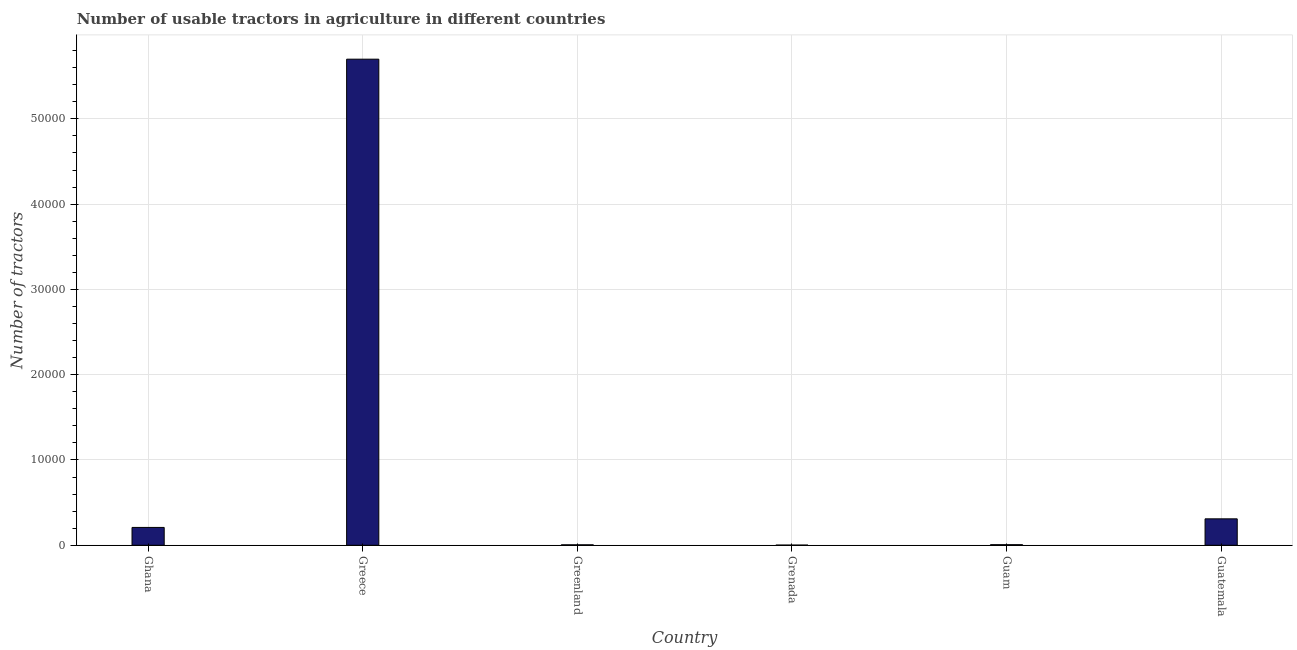Does the graph contain grids?
Offer a terse response. Yes. What is the title of the graph?
Ensure brevity in your answer.  Number of usable tractors in agriculture in different countries. What is the label or title of the Y-axis?
Your answer should be compact. Number of tractors. What is the number of tractors in Guam?
Provide a succinct answer. 68. Across all countries, what is the maximum number of tractors?
Your answer should be compact. 5.70e+04. Across all countries, what is the minimum number of tractors?
Ensure brevity in your answer.  22. In which country was the number of tractors minimum?
Your response must be concise. Grenada. What is the sum of the number of tractors?
Keep it short and to the point. 6.23e+04. What is the difference between the number of tractors in Greece and Grenada?
Give a very brief answer. 5.70e+04. What is the average number of tractors per country?
Your answer should be compact. 1.04e+04. What is the median number of tractors?
Your response must be concise. 1080. In how many countries, is the number of tractors greater than 42000 ?
Offer a very short reply. 1. What is the ratio of the number of tractors in Ghana to that in Grenada?
Make the answer very short. 95.09. Is the number of tractors in Greenland less than that in Guam?
Ensure brevity in your answer.  Yes. Is the difference between the number of tractors in Greenland and Guam greater than the difference between any two countries?
Offer a terse response. No. What is the difference between the highest and the second highest number of tractors?
Provide a succinct answer. 5.39e+04. Is the sum of the number of tractors in Grenada and Guam greater than the maximum number of tractors across all countries?
Offer a terse response. No. What is the difference between the highest and the lowest number of tractors?
Make the answer very short. 5.70e+04. What is the difference between two consecutive major ticks on the Y-axis?
Offer a very short reply. 10000. What is the Number of tractors in Ghana?
Your response must be concise. 2092. What is the Number of tractors of Greece?
Ensure brevity in your answer.  5.70e+04. What is the Number of tractors in Guatemala?
Keep it short and to the point. 3100. What is the difference between the Number of tractors in Ghana and Greece?
Your answer should be compact. -5.49e+04. What is the difference between the Number of tractors in Ghana and Greenland?
Provide a short and direct response. 2038. What is the difference between the Number of tractors in Ghana and Grenada?
Your response must be concise. 2070. What is the difference between the Number of tractors in Ghana and Guam?
Ensure brevity in your answer.  2024. What is the difference between the Number of tractors in Ghana and Guatemala?
Your answer should be very brief. -1008. What is the difference between the Number of tractors in Greece and Greenland?
Your response must be concise. 5.69e+04. What is the difference between the Number of tractors in Greece and Grenada?
Provide a short and direct response. 5.70e+04. What is the difference between the Number of tractors in Greece and Guam?
Provide a succinct answer. 5.69e+04. What is the difference between the Number of tractors in Greece and Guatemala?
Your response must be concise. 5.39e+04. What is the difference between the Number of tractors in Greenland and Guatemala?
Provide a succinct answer. -3046. What is the difference between the Number of tractors in Grenada and Guam?
Your answer should be very brief. -46. What is the difference between the Number of tractors in Grenada and Guatemala?
Give a very brief answer. -3078. What is the difference between the Number of tractors in Guam and Guatemala?
Provide a succinct answer. -3032. What is the ratio of the Number of tractors in Ghana to that in Greece?
Make the answer very short. 0.04. What is the ratio of the Number of tractors in Ghana to that in Greenland?
Your answer should be very brief. 38.74. What is the ratio of the Number of tractors in Ghana to that in Grenada?
Provide a short and direct response. 95.09. What is the ratio of the Number of tractors in Ghana to that in Guam?
Ensure brevity in your answer.  30.77. What is the ratio of the Number of tractors in Ghana to that in Guatemala?
Make the answer very short. 0.68. What is the ratio of the Number of tractors in Greece to that in Greenland?
Provide a succinct answer. 1055.56. What is the ratio of the Number of tractors in Greece to that in Grenada?
Your answer should be very brief. 2590.91. What is the ratio of the Number of tractors in Greece to that in Guam?
Offer a terse response. 838.24. What is the ratio of the Number of tractors in Greece to that in Guatemala?
Your answer should be very brief. 18.39. What is the ratio of the Number of tractors in Greenland to that in Grenada?
Ensure brevity in your answer.  2.46. What is the ratio of the Number of tractors in Greenland to that in Guam?
Give a very brief answer. 0.79. What is the ratio of the Number of tractors in Greenland to that in Guatemala?
Offer a terse response. 0.02. What is the ratio of the Number of tractors in Grenada to that in Guam?
Provide a succinct answer. 0.32. What is the ratio of the Number of tractors in Grenada to that in Guatemala?
Offer a terse response. 0.01. What is the ratio of the Number of tractors in Guam to that in Guatemala?
Keep it short and to the point. 0.02. 